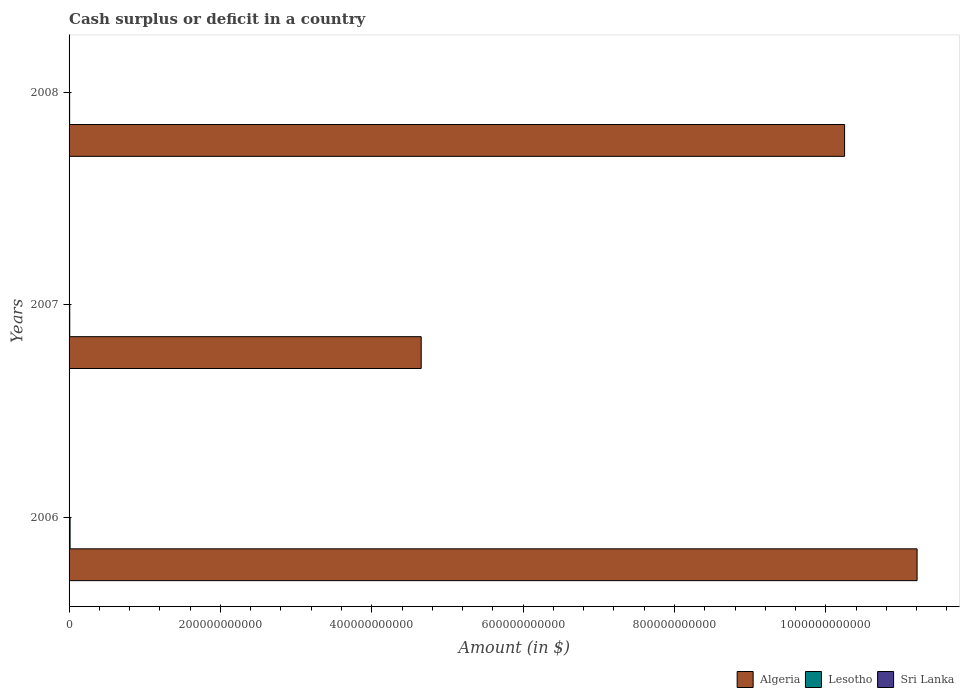Are the number of bars on each tick of the Y-axis equal?
Offer a terse response. Yes. How many bars are there on the 1st tick from the bottom?
Your answer should be very brief. 2. In how many cases, is the number of bars for a given year not equal to the number of legend labels?
Give a very brief answer. 3. What is the amount of cash surplus or deficit in Lesotho in 2006?
Make the answer very short. 1.35e+09. Across all years, what is the maximum amount of cash surplus or deficit in Algeria?
Offer a terse response. 1.12e+12. Across all years, what is the minimum amount of cash surplus or deficit in Lesotho?
Make the answer very short. 7.59e+08. In which year was the amount of cash surplus or deficit in Algeria maximum?
Provide a succinct answer. 2006. What is the total amount of cash surplus or deficit in Algeria in the graph?
Your response must be concise. 2.61e+12. What is the difference between the amount of cash surplus or deficit in Algeria in 2007 and that in 2008?
Your answer should be very brief. -5.59e+11. What is the difference between the amount of cash surplus or deficit in Algeria in 2008 and the amount of cash surplus or deficit in Lesotho in 2007?
Give a very brief answer. 1.02e+12. What is the average amount of cash surplus or deficit in Algeria per year?
Keep it short and to the point. 8.70e+11. In the year 2008, what is the difference between the amount of cash surplus or deficit in Algeria and amount of cash surplus or deficit in Lesotho?
Ensure brevity in your answer.  1.02e+12. What is the ratio of the amount of cash surplus or deficit in Algeria in 2006 to that in 2008?
Offer a very short reply. 1.09. What is the difference between the highest and the second highest amount of cash surplus or deficit in Algeria?
Make the answer very short. 9.58e+1. What is the difference between the highest and the lowest amount of cash surplus or deficit in Lesotho?
Give a very brief answer. 5.90e+08. Is it the case that in every year, the sum of the amount of cash surplus or deficit in Sri Lanka and amount of cash surplus or deficit in Lesotho is greater than the amount of cash surplus or deficit in Algeria?
Provide a short and direct response. No. Are all the bars in the graph horizontal?
Make the answer very short. Yes. What is the difference between two consecutive major ticks on the X-axis?
Provide a succinct answer. 2.00e+11. Are the values on the major ticks of X-axis written in scientific E-notation?
Your answer should be very brief. No. Does the graph contain any zero values?
Provide a short and direct response. Yes. Does the graph contain grids?
Give a very brief answer. No. How are the legend labels stacked?
Keep it short and to the point. Horizontal. What is the title of the graph?
Offer a terse response. Cash surplus or deficit in a country. What is the label or title of the X-axis?
Keep it short and to the point. Amount (in $). What is the label or title of the Y-axis?
Make the answer very short. Years. What is the Amount (in $) in Algeria in 2006?
Provide a short and direct response. 1.12e+12. What is the Amount (in $) of Lesotho in 2006?
Your response must be concise. 1.35e+09. What is the Amount (in $) in Algeria in 2007?
Provide a short and direct response. 4.65e+11. What is the Amount (in $) of Lesotho in 2007?
Provide a short and direct response. 8.95e+08. What is the Amount (in $) in Sri Lanka in 2007?
Provide a short and direct response. 0. What is the Amount (in $) of Algeria in 2008?
Provide a succinct answer. 1.02e+12. What is the Amount (in $) in Lesotho in 2008?
Offer a terse response. 7.59e+08. Across all years, what is the maximum Amount (in $) of Algeria?
Provide a succinct answer. 1.12e+12. Across all years, what is the maximum Amount (in $) in Lesotho?
Offer a terse response. 1.35e+09. Across all years, what is the minimum Amount (in $) of Algeria?
Give a very brief answer. 4.65e+11. Across all years, what is the minimum Amount (in $) in Lesotho?
Make the answer very short. 7.59e+08. What is the total Amount (in $) of Algeria in the graph?
Offer a terse response. 2.61e+12. What is the total Amount (in $) in Lesotho in the graph?
Keep it short and to the point. 3.00e+09. What is the total Amount (in $) of Sri Lanka in the graph?
Provide a succinct answer. 0. What is the difference between the Amount (in $) in Algeria in 2006 and that in 2007?
Give a very brief answer. 6.55e+11. What is the difference between the Amount (in $) of Lesotho in 2006 and that in 2007?
Your response must be concise. 4.54e+08. What is the difference between the Amount (in $) in Algeria in 2006 and that in 2008?
Your answer should be compact. 9.58e+1. What is the difference between the Amount (in $) of Lesotho in 2006 and that in 2008?
Give a very brief answer. 5.90e+08. What is the difference between the Amount (in $) in Algeria in 2007 and that in 2008?
Your answer should be very brief. -5.59e+11. What is the difference between the Amount (in $) in Lesotho in 2007 and that in 2008?
Give a very brief answer. 1.36e+08. What is the difference between the Amount (in $) of Algeria in 2006 and the Amount (in $) of Lesotho in 2007?
Your answer should be compact. 1.12e+12. What is the difference between the Amount (in $) in Algeria in 2006 and the Amount (in $) in Lesotho in 2008?
Your answer should be compact. 1.12e+12. What is the difference between the Amount (in $) of Algeria in 2007 and the Amount (in $) of Lesotho in 2008?
Your answer should be very brief. 4.65e+11. What is the average Amount (in $) in Algeria per year?
Provide a succinct answer. 8.70e+11. What is the average Amount (in $) in Lesotho per year?
Give a very brief answer. 1.00e+09. What is the average Amount (in $) of Sri Lanka per year?
Offer a terse response. 0. In the year 2006, what is the difference between the Amount (in $) in Algeria and Amount (in $) in Lesotho?
Offer a very short reply. 1.12e+12. In the year 2007, what is the difference between the Amount (in $) of Algeria and Amount (in $) of Lesotho?
Ensure brevity in your answer.  4.64e+11. In the year 2008, what is the difference between the Amount (in $) in Algeria and Amount (in $) in Lesotho?
Your answer should be compact. 1.02e+12. What is the ratio of the Amount (in $) of Algeria in 2006 to that in 2007?
Provide a succinct answer. 2.41. What is the ratio of the Amount (in $) in Lesotho in 2006 to that in 2007?
Offer a very short reply. 1.51. What is the ratio of the Amount (in $) of Algeria in 2006 to that in 2008?
Provide a short and direct response. 1.09. What is the ratio of the Amount (in $) in Lesotho in 2006 to that in 2008?
Provide a short and direct response. 1.78. What is the ratio of the Amount (in $) in Algeria in 2007 to that in 2008?
Keep it short and to the point. 0.45. What is the ratio of the Amount (in $) of Lesotho in 2007 to that in 2008?
Your answer should be very brief. 1.18. What is the difference between the highest and the second highest Amount (in $) in Algeria?
Your response must be concise. 9.58e+1. What is the difference between the highest and the second highest Amount (in $) of Lesotho?
Provide a short and direct response. 4.54e+08. What is the difference between the highest and the lowest Amount (in $) of Algeria?
Keep it short and to the point. 6.55e+11. What is the difference between the highest and the lowest Amount (in $) in Lesotho?
Ensure brevity in your answer.  5.90e+08. 